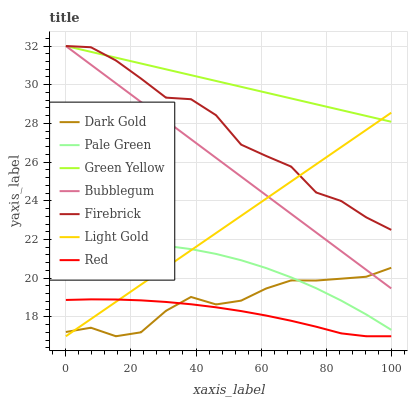Does Red have the minimum area under the curve?
Answer yes or no. Yes. Does Green Yellow have the maximum area under the curve?
Answer yes or no. Yes. Does Firebrick have the minimum area under the curve?
Answer yes or no. No. Does Firebrick have the maximum area under the curve?
Answer yes or no. No. Is Bubblegum the smoothest?
Answer yes or no. Yes. Is Firebrick the roughest?
Answer yes or no. Yes. Is Firebrick the smoothest?
Answer yes or no. No. Is Bubblegum the roughest?
Answer yes or no. No. Does Dark Gold have the lowest value?
Answer yes or no. Yes. Does Firebrick have the lowest value?
Answer yes or no. No. Does Green Yellow have the highest value?
Answer yes or no. Yes. Does Pale Green have the highest value?
Answer yes or no. No. Is Red less than Pale Green?
Answer yes or no. Yes. Is Green Yellow greater than Red?
Answer yes or no. Yes. Does Dark Gold intersect Red?
Answer yes or no. Yes. Is Dark Gold less than Red?
Answer yes or no. No. Is Dark Gold greater than Red?
Answer yes or no. No. Does Red intersect Pale Green?
Answer yes or no. No. 